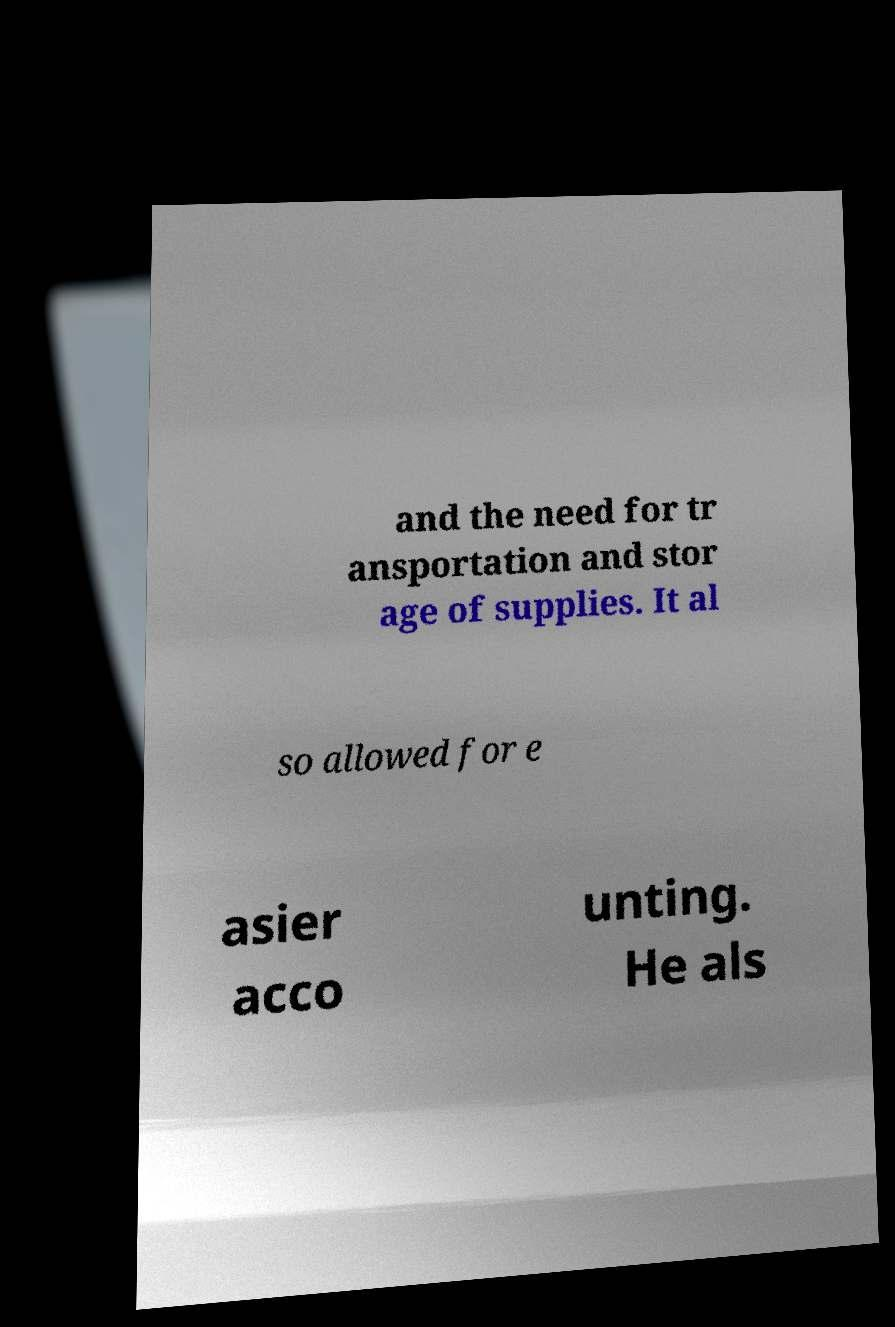Can you read and provide the text displayed in the image?This photo seems to have some interesting text. Can you extract and type it out for me? and the need for tr ansportation and stor age of supplies. It al so allowed for e asier acco unting. He als 